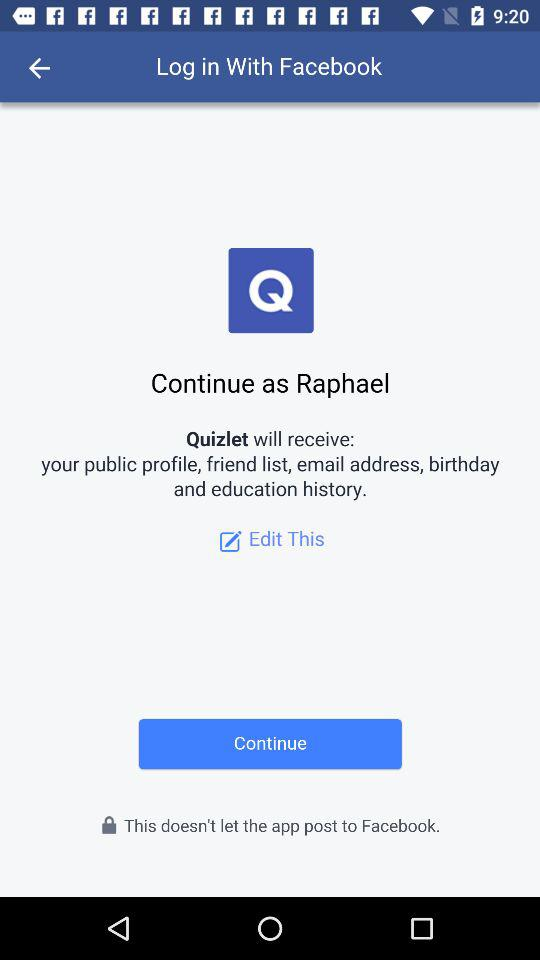With what application can we log in? You can log in with "Facebook". 